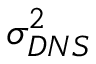Convert formula to latex. <formula><loc_0><loc_0><loc_500><loc_500>\sigma _ { D N S } ^ { 2 }</formula> 